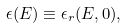Convert formula to latex. <formula><loc_0><loc_0><loc_500><loc_500>\epsilon ( E ) \equiv \epsilon _ { r } ( E , 0 ) ,</formula> 